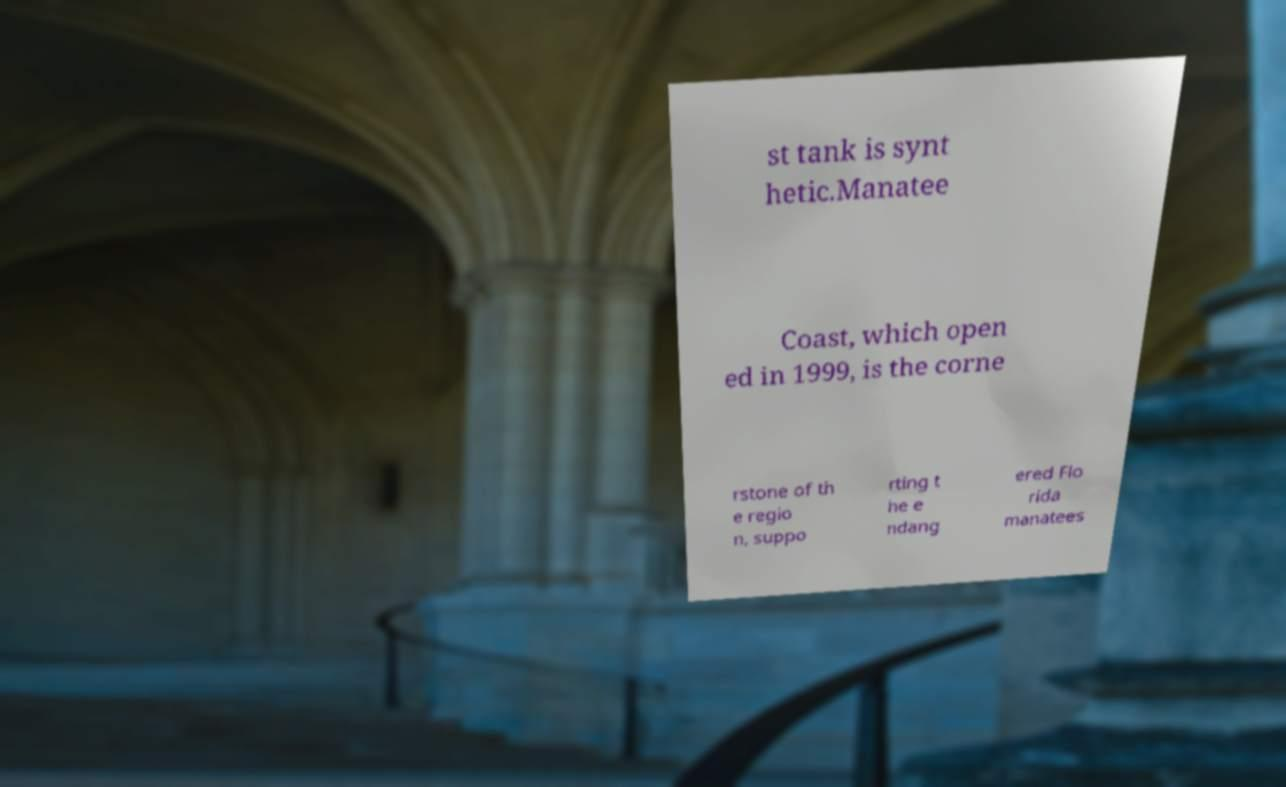For documentation purposes, I need the text within this image transcribed. Could you provide that? st tank is synt hetic.Manatee Coast, which open ed in 1999, is the corne rstone of th e regio n, suppo rting t he e ndang ered Flo rida manatees 